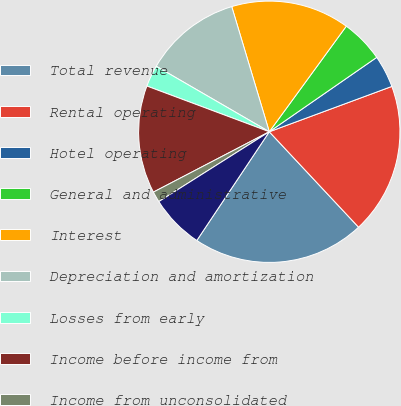Convert chart to OTSL. <chart><loc_0><loc_0><loc_500><loc_500><pie_chart><fcel>Total revenue<fcel>Rental operating<fcel>Hotel operating<fcel>General and administrative<fcel>Interest<fcel>Depreciation and amortization<fcel>Losses from early<fcel>Income before income from<fcel>Income from unconsolidated<fcel>Minority interests<nl><fcel>21.33%<fcel>18.67%<fcel>4.0%<fcel>5.33%<fcel>14.67%<fcel>12.0%<fcel>2.67%<fcel>13.33%<fcel>1.33%<fcel>6.67%<nl></chart> 